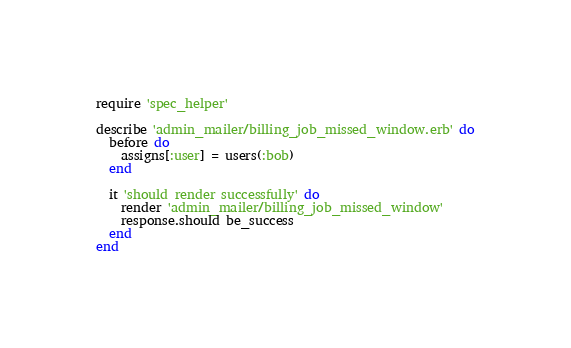Convert code to text. <code><loc_0><loc_0><loc_500><loc_500><_Ruby_>require 'spec_helper'

describe 'admin_mailer/billing_job_missed_window.erb' do
  before do
    assigns[:user] = users(:bob)
  end

  it 'should render successfully' do
    render 'admin_mailer/billing_job_missed_window'
    response.should be_success
  end
end
</code> 